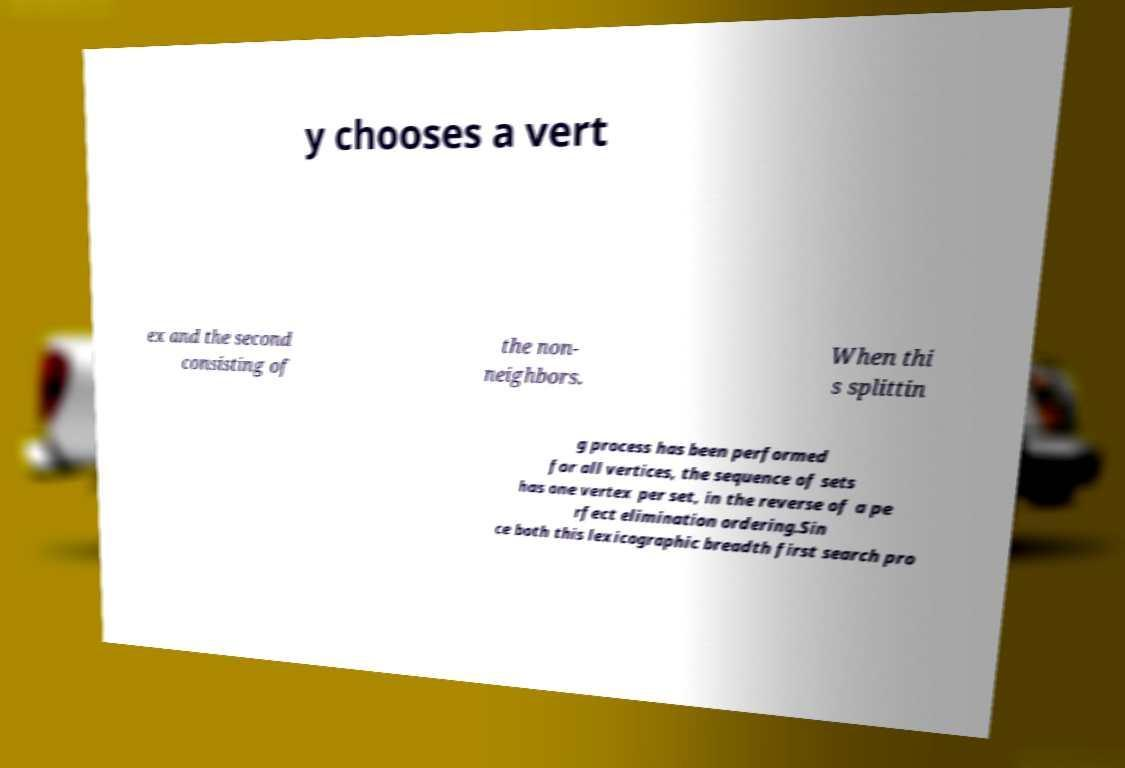Please read and relay the text visible in this image. What does it say? y chooses a vert ex and the second consisting of the non- neighbors. When thi s splittin g process has been performed for all vertices, the sequence of sets has one vertex per set, in the reverse of a pe rfect elimination ordering.Sin ce both this lexicographic breadth first search pro 